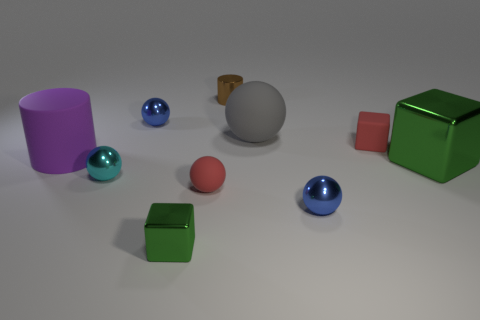Subtract 2 spheres. How many spheres are left? 3 Subtract all cyan spheres. How many spheres are left? 4 Subtract all small cyan shiny spheres. How many spheres are left? 4 Subtract all green spheres. Subtract all red blocks. How many spheres are left? 5 Subtract all cylinders. How many objects are left? 8 Subtract all matte cylinders. Subtract all small green matte cylinders. How many objects are left? 9 Add 6 rubber cylinders. How many rubber cylinders are left? 7 Add 9 big blue metallic cubes. How many big blue metallic cubes exist? 9 Subtract 0 cyan cylinders. How many objects are left? 10 